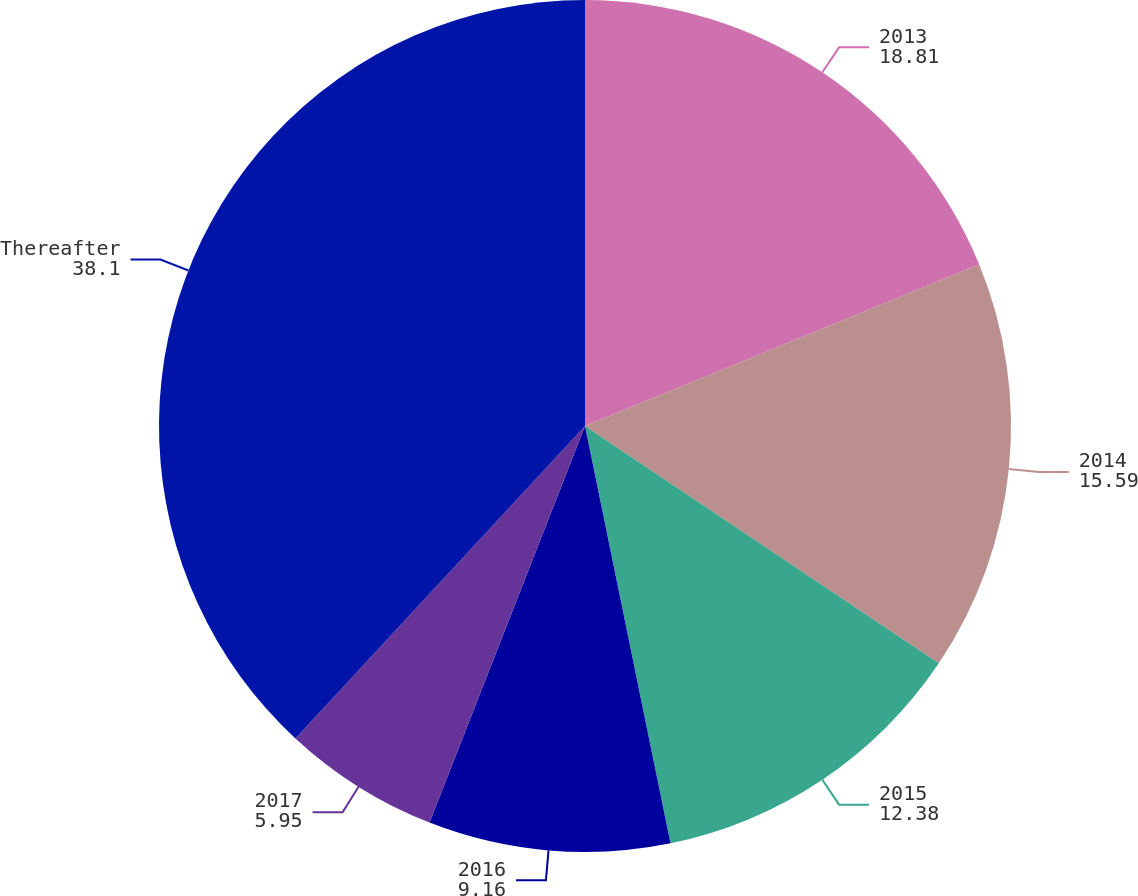<chart> <loc_0><loc_0><loc_500><loc_500><pie_chart><fcel>2013<fcel>2014<fcel>2015<fcel>2016<fcel>2017<fcel>Thereafter<nl><fcel>18.81%<fcel>15.59%<fcel>12.38%<fcel>9.16%<fcel>5.95%<fcel>38.1%<nl></chart> 